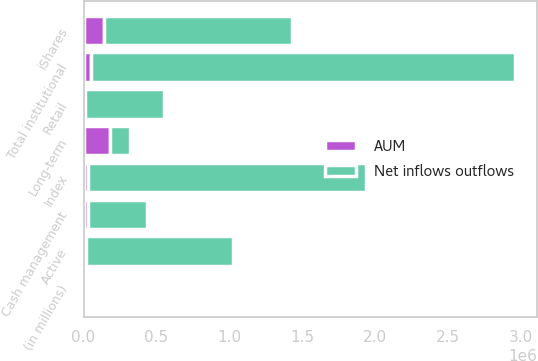Convert chart. <chart><loc_0><loc_0><loc_500><loc_500><stacked_bar_chart><ecel><fcel>(in millions)<fcel>Retail<fcel>iShares<fcel>Active<fcel>Index<fcel>Total institutional<fcel>Long-term<fcel>Cash management<nl><fcel>Net inflows outflows<fcel>2016<fcel>541952<fcel>1.28788e+06<fcel>1.00997e+06<fcel>1.90168e+06<fcel>2.91166e+06<fcel>140479<fcel>403584<nl><fcel>AUM<fcel>2016<fcel>11324<fcel>140479<fcel>17918<fcel>33491<fcel>51409<fcel>180564<fcel>29228<nl></chart> 